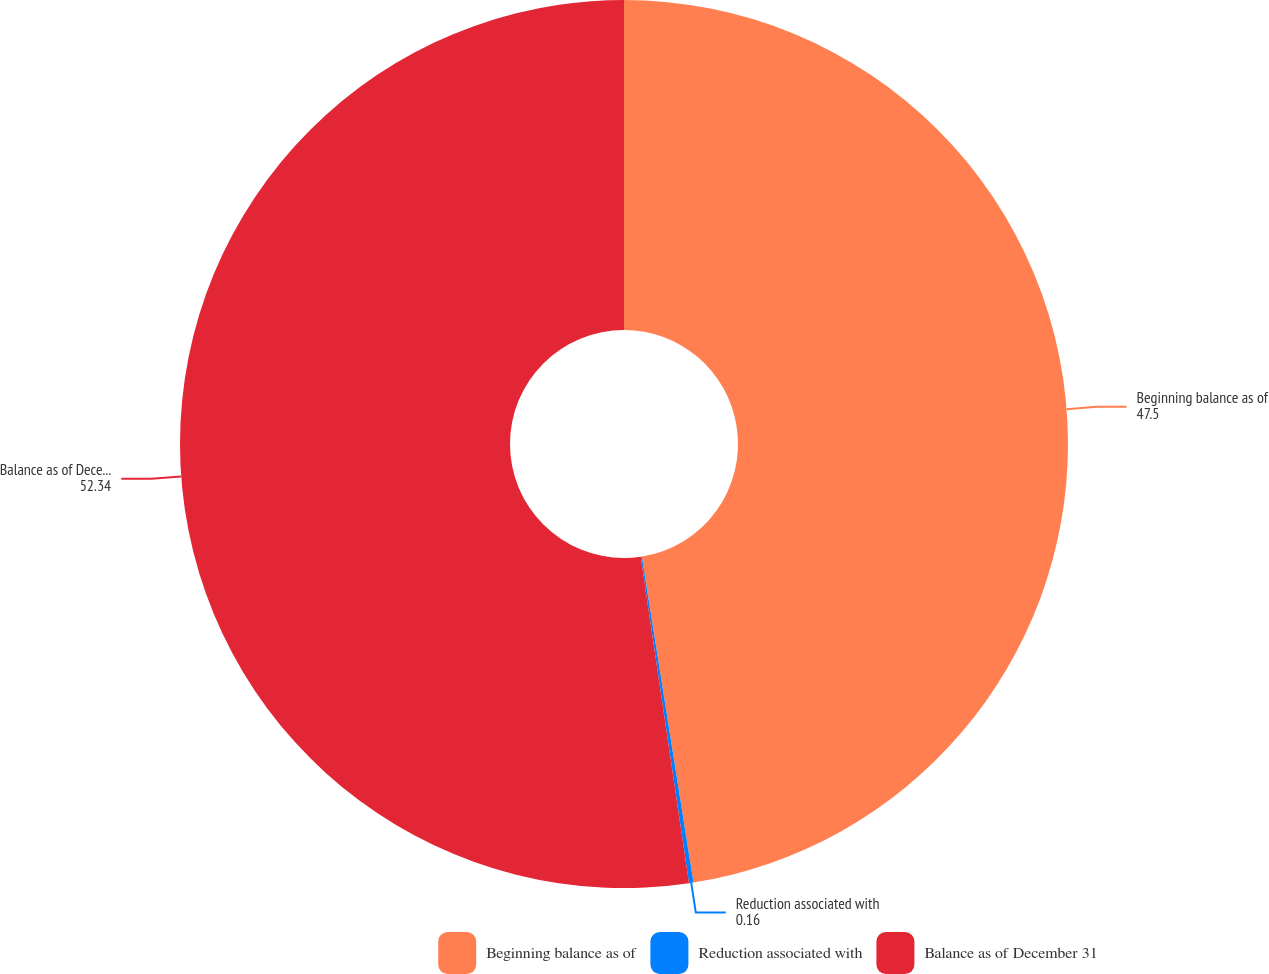Convert chart to OTSL. <chart><loc_0><loc_0><loc_500><loc_500><pie_chart><fcel>Beginning balance as of<fcel>Reduction associated with<fcel>Balance as of December 31<nl><fcel>47.5%<fcel>0.16%<fcel>52.34%<nl></chart> 